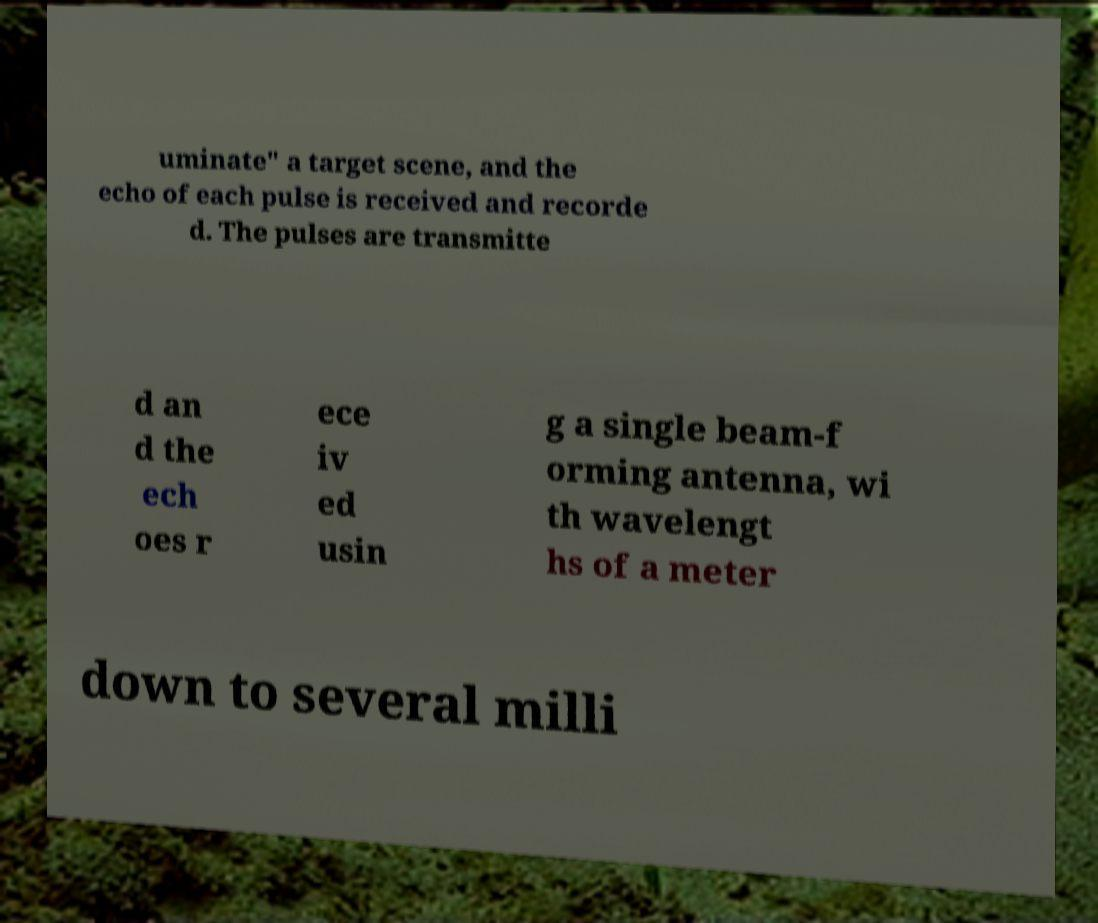Can you accurately transcribe the text from the provided image for me? uminate" a target scene, and the echo of each pulse is received and recorde d. The pulses are transmitte d an d the ech oes r ece iv ed usin g a single beam-f orming antenna, wi th wavelengt hs of a meter down to several milli 